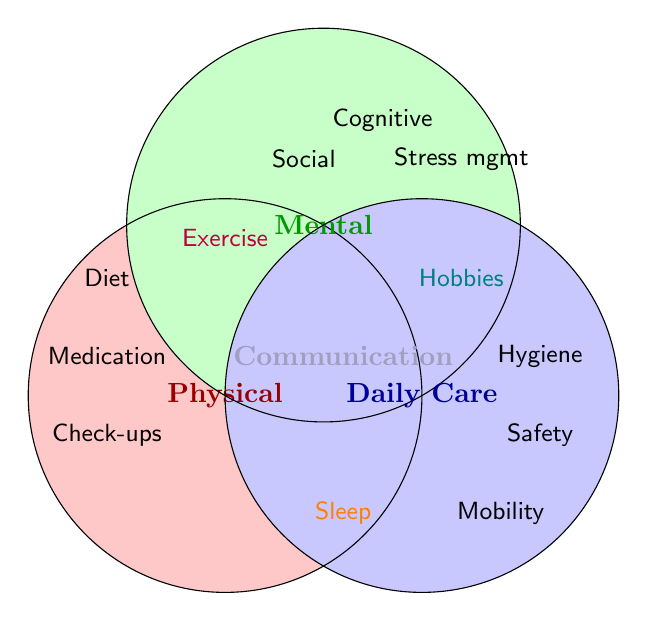How many categories are represented in the Venn diagram? The Venn diagram uses three main circles, indicating the number of represented categories.
Answer: 3 What are some items listed under the 'Physical Health' category only? Items specifically within the 'Physical Health' circle and not overlapping with others include "Regular check-ups," "Medication management," and "Balanced diet."
Answer: Regular check-ups, Medication management, Balanced diet Which item overlaps all three categories? The item located at the intersection of all three circles represents the overlap across all categories.
Answer: Regular communication Name one item that affects both 'Physical Health' and 'Daily Care' but not 'Mental Health'. The item placed in the overlapping area of 'Physical Health' and 'Daily Care' categories but not within the 'Mental Health' section fits this description.
Answer: Adequate sleep Which category contains 'Cognitive activities'? 'Cognitive activities' is located within the 'Mental Health' circle.
Answer: Mental Health What combination of categories does 'Exercise routines' fall under? 'Exercise routines' falls in the overlapping region between 'Physical Health' and 'Mental Health.'
Answer: Physical Health and Mental Health Identify an item that overlaps 'Mental Health' and 'Daily Care'. The item situated in the joint area shared by 'Mental Health' and 'Daily Care' would be the answer.
Answer: Engaging hobbies List the main activities represented under the 'Daily Care' category only. 'Daily Care' specific items, excluding overlaps, are those found solely within the 'Daily Care' circle.
Answer: Personal hygiene, Home safety, Mobility assistance 